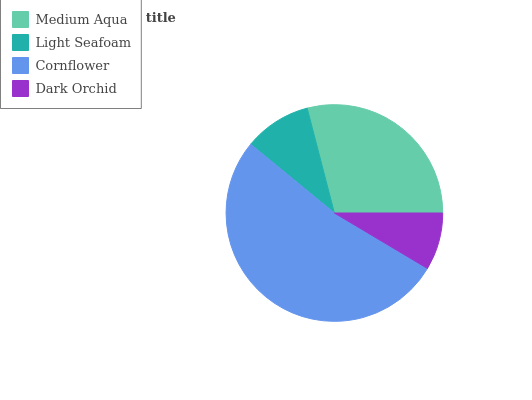Is Dark Orchid the minimum?
Answer yes or no. Yes. Is Cornflower the maximum?
Answer yes or no. Yes. Is Light Seafoam the minimum?
Answer yes or no. No. Is Light Seafoam the maximum?
Answer yes or no. No. Is Medium Aqua greater than Light Seafoam?
Answer yes or no. Yes. Is Light Seafoam less than Medium Aqua?
Answer yes or no. Yes. Is Light Seafoam greater than Medium Aqua?
Answer yes or no. No. Is Medium Aqua less than Light Seafoam?
Answer yes or no. No. Is Medium Aqua the high median?
Answer yes or no. Yes. Is Light Seafoam the low median?
Answer yes or no. Yes. Is Dark Orchid the high median?
Answer yes or no. No. Is Dark Orchid the low median?
Answer yes or no. No. 